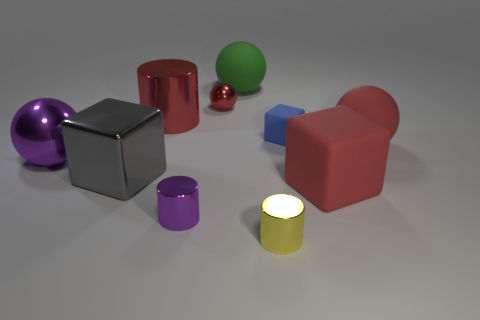Is the size of the red thing that is in front of the large red ball the same as the red sphere that is to the right of the small red sphere? It appears that the sizes differ slightly. The red cylindrical object in front of the large red ball seems to have a larger diameter, while the red sphere to the right of the small red sphere is comparatively smaller. 